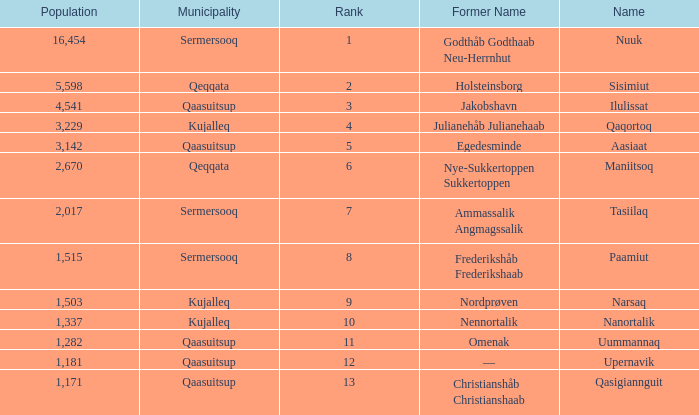Who has a former name of nordprøven? Narsaq. 